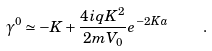Convert formula to latex. <formula><loc_0><loc_0><loc_500><loc_500>\gamma ^ { 0 } \simeq - K + \frac { 4 i q K ^ { 2 } } { 2 m V _ { 0 } } e ^ { - 2 K a } \quad .</formula> 